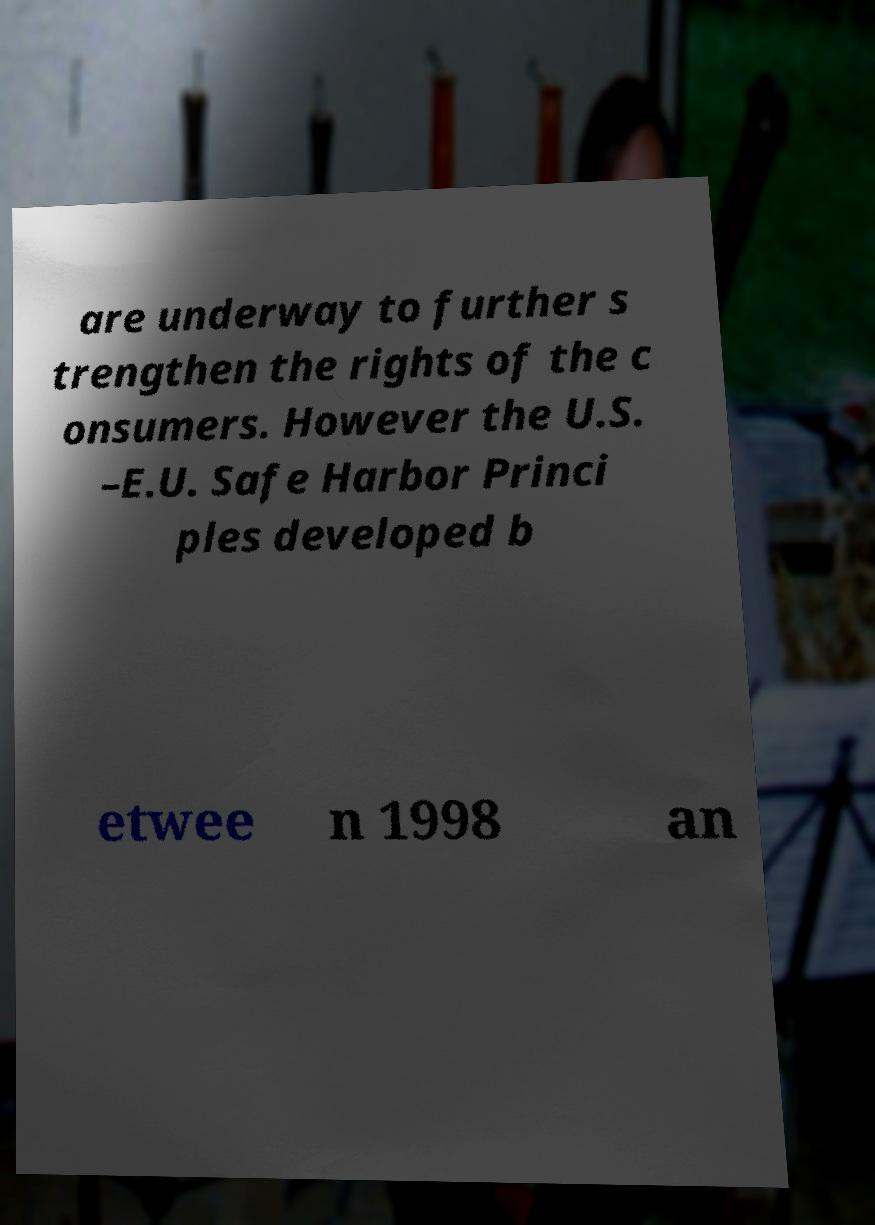What messages or text are displayed in this image? I need them in a readable, typed format. are underway to further s trengthen the rights of the c onsumers. However the U.S. –E.U. Safe Harbor Princi ples developed b etwee n 1998 an 